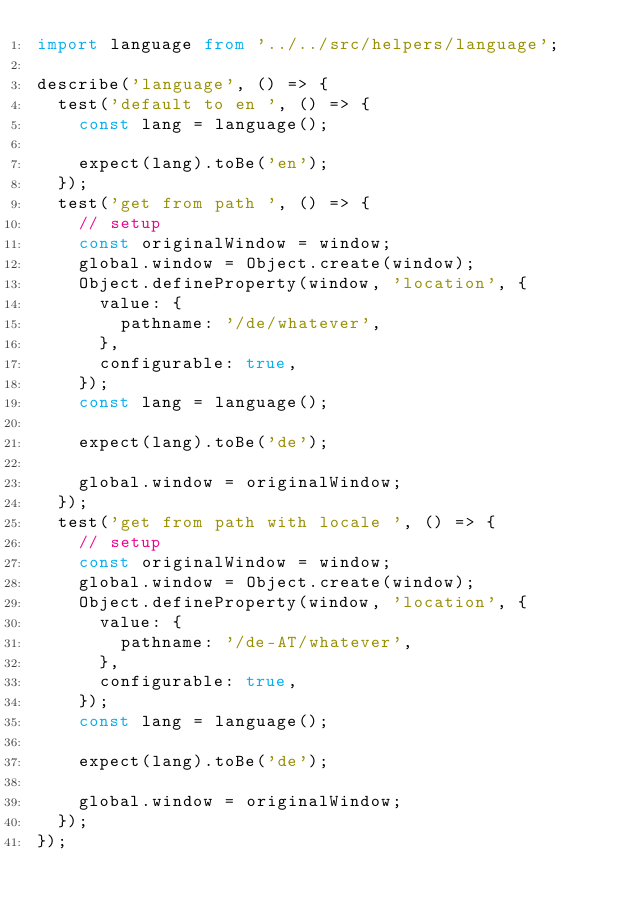<code> <loc_0><loc_0><loc_500><loc_500><_TypeScript_>import language from '../../src/helpers/language';

describe('language', () => {
  test('default to en ', () => {
    const lang = language();

    expect(lang).toBe('en');
  });
  test('get from path ', () => {
    // setup
    const originalWindow = window;
    global.window = Object.create(window);
    Object.defineProperty(window, 'location', {
      value: {
        pathname: '/de/whatever',
      },
      configurable: true,
    });
    const lang = language();

    expect(lang).toBe('de');

    global.window = originalWindow;
  });
  test('get from path with locale ', () => {
    // setup
    const originalWindow = window;
    global.window = Object.create(window);
    Object.defineProperty(window, 'location', {
      value: {
        pathname: '/de-AT/whatever',
      },
      configurable: true,
    });
    const lang = language();

    expect(lang).toBe('de');

    global.window = originalWindow;
  });
});
</code> 